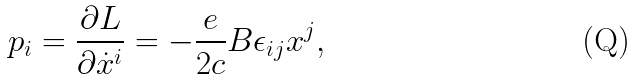<formula> <loc_0><loc_0><loc_500><loc_500>p _ { i } = \frac { \partial L } { \partial \dot { x } ^ { i } } = - \frac { e } { 2 c } B \epsilon _ { i j } x ^ { j } ,</formula> 